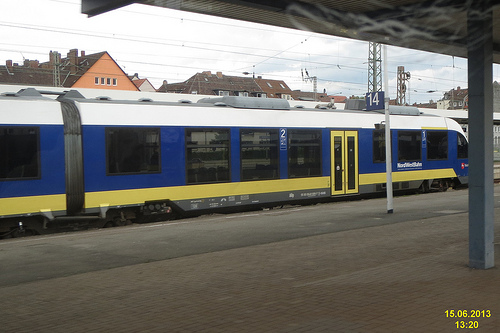What can this image tell us about public transportation in this region? The image suggests a well-maintained and modern public transportation system. The presence of a bi-level passenger train indicates a potentially high demand for transit services, implying a possible emphasis on sustainable and efficient urban transportation solutions in this area. 